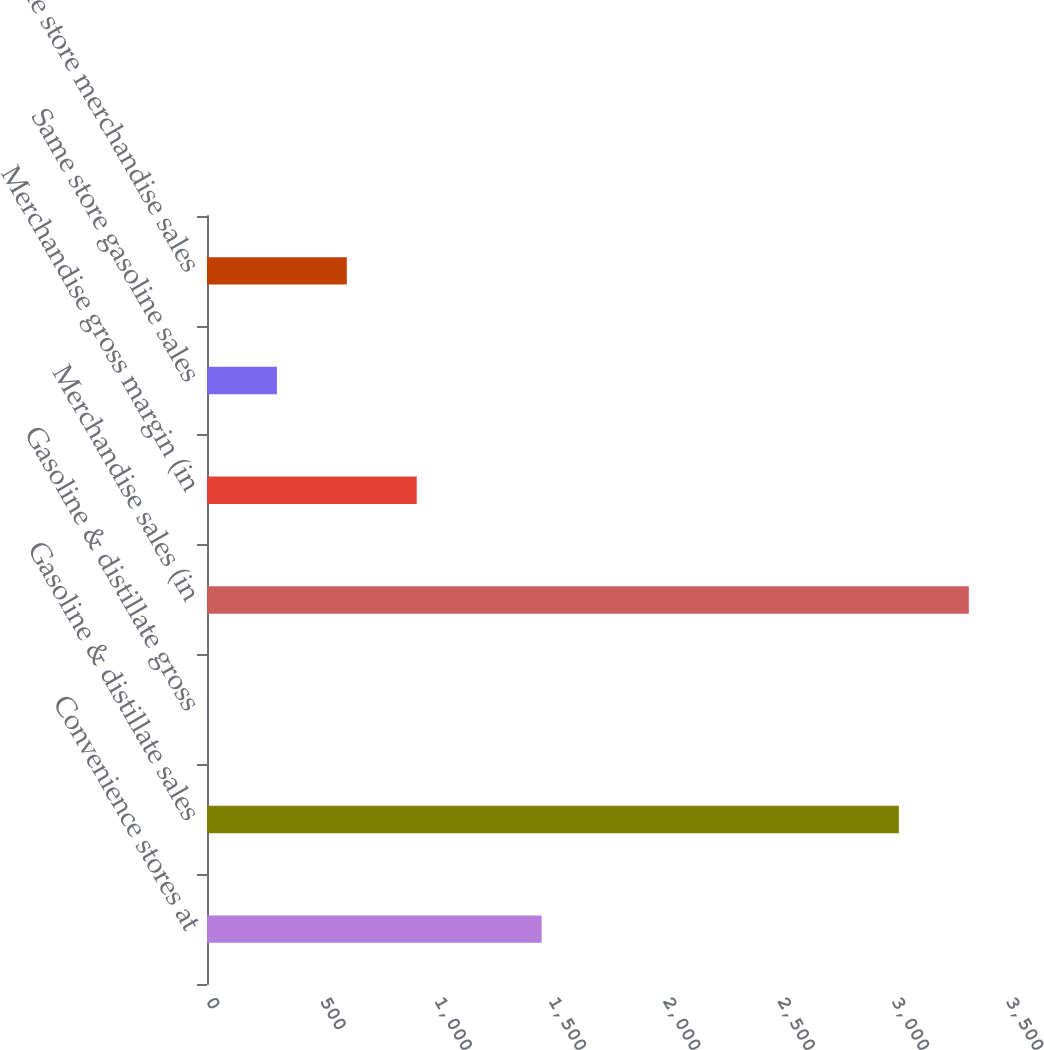Convert chart. <chart><loc_0><loc_0><loc_500><loc_500><bar_chart><fcel>Convenience stores at<fcel>Gasoline & distillate sales<fcel>Gasoline & distillate gross<fcel>Merchandise sales (in<fcel>Merchandise gross margin (in<fcel>Same store gasoline sales<fcel>Same store merchandise sales<nl><fcel>1464<fcel>3027<fcel>0.13<fcel>3332.79<fcel>917.5<fcel>305.92<fcel>611.71<nl></chart> 